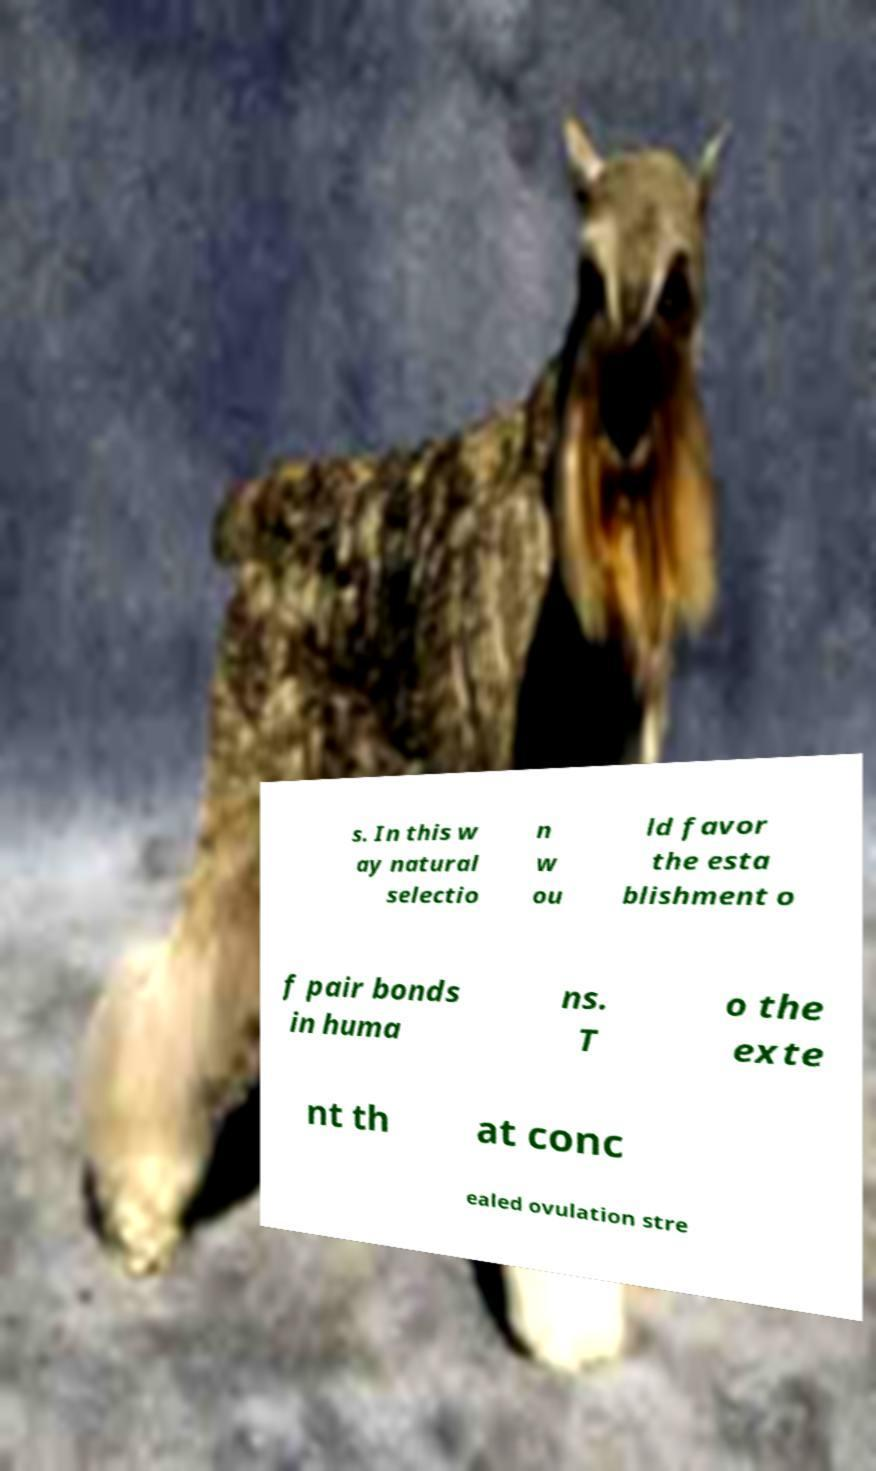I need the written content from this picture converted into text. Can you do that? s. In this w ay natural selectio n w ou ld favor the esta blishment o f pair bonds in huma ns. T o the exte nt th at conc ealed ovulation stre 